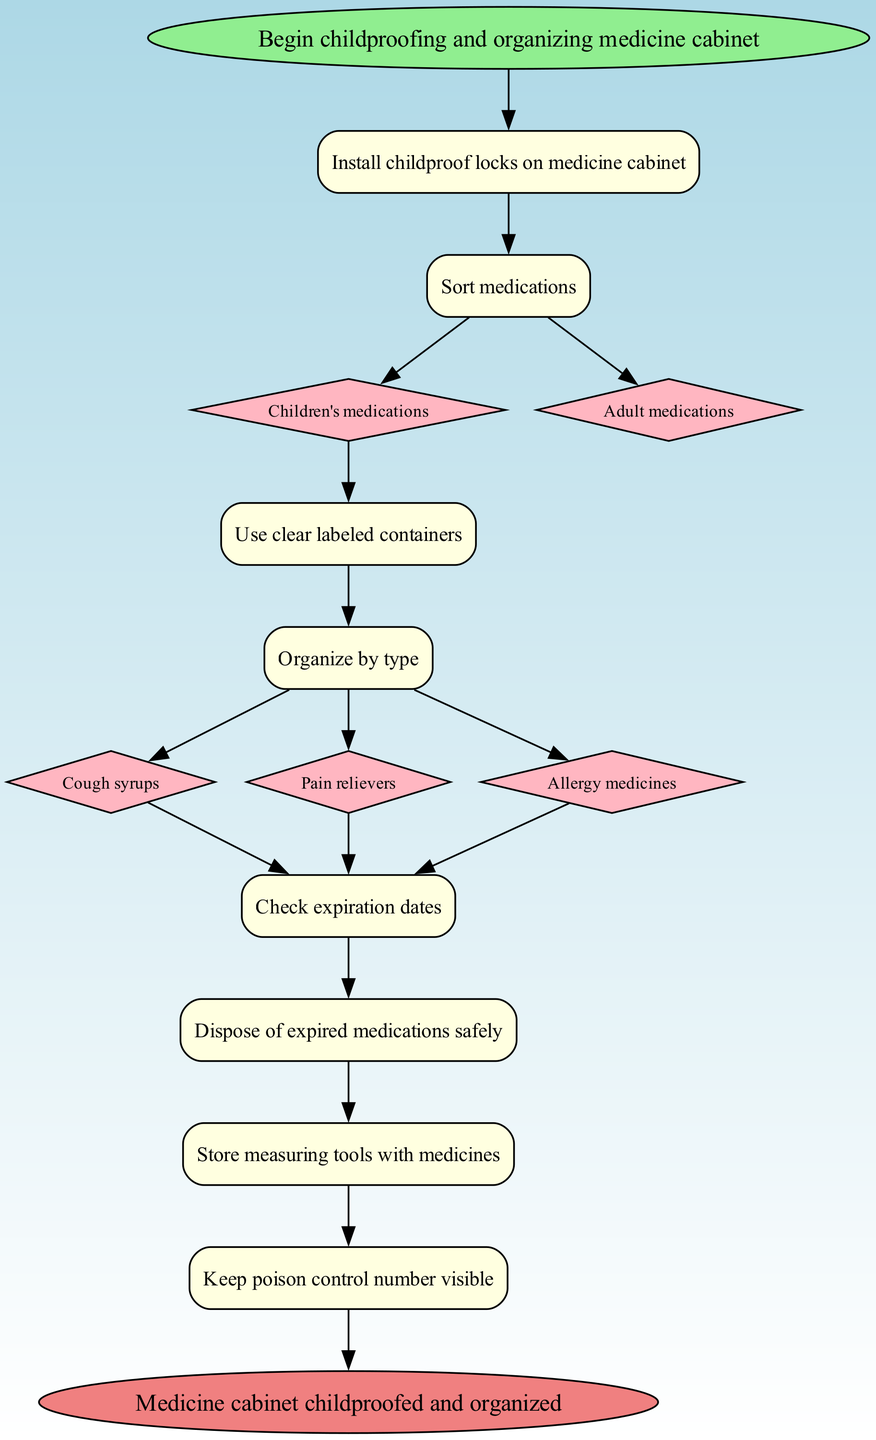What is the first action to take in the diagram? The diagram starts with the action labeled "Begin childproofing and organizing medicine cabinet." This node is directly connected to the next action indicating its position in the sequence.
Answer: Begin childproofing and organizing medicine cabinet How many options are provided in the "Sort medications" step? The "Sort medications" step contains two options: "Children's medications" and "Adult medications." This can be counted from the options listed under this node.
Answer: 2 What do you do after using clear labeled containers? After using clear labeled containers, the next step indicated in the diagram is "Organize by type." This can be found as the direct next action linked from the containers step.
Answer: Organize by type Which type of medications are checked for expiration dates? The types of medications that are checked for expiration dates in the diagram are "Cough syrups," "Pain relievers," and "Allergy medicines." This information is outlined in the organization step where these types are explicitly mentioned.
Answer: Cough syrups, Pain relievers, Allergy medicines What is the final action indicated in the diagram? The final action, as stated in the end node of the diagram, is "Medicine cabinet childproofed and organized." This is reached by following the flow of actions leading up to the end node.
Answer: Medicine cabinet childproofed and organized What comes after disposing of expired medications safely? The step that follows disposing of expired medications safely is "Store measuring tools with medicines." This is determined by looking at the action that is linked directly after the disposal action in the flow.
Answer: Store measuring tools with medicines What should be done monthly according to the diagram? The diagram indicates that "Review organization monthly" is the action to be performed monthly. This is shown as the last action before reaching the end of the diagram.
Answer: Review organization monthly Which step requires childproof locks? The first step listed instructs to "Install childproof locks on medicine cabinet." This is the initial action aimed at enhancing safety from the beginning of the process.
Answer: Install childproof locks on medicine cabinet 